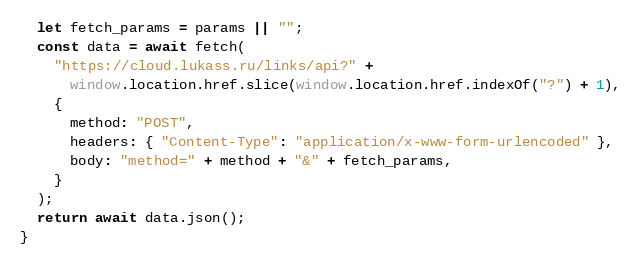Convert code to text. <code><loc_0><loc_0><loc_500><loc_500><_JavaScript_>  let fetch_params = params || "";
  const data = await fetch(
    "https://cloud.lukass.ru/links/api?" +
      window.location.href.slice(window.location.href.indexOf("?") + 1),
    {
      method: "POST",
      headers: { "Content-Type": "application/x-www-form-urlencoded" },
      body: "method=" + method + "&" + fetch_params,
    }
  );
  return await data.json();
}
</code> 